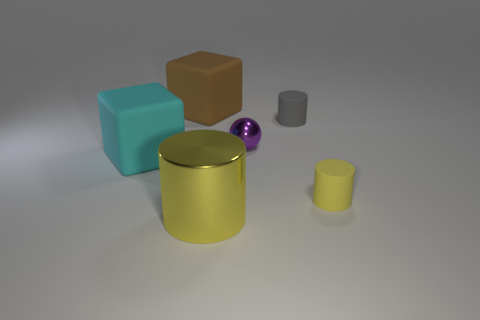What could these objects represent if they were symbolic? If we interpret the objects symbolically, the variety of geometric shapes and colors might represent diversity and individuality. The central yellow cylinder could symbolize a source of energy or light, the blocks might represent structure and stability, while the purple sphere could signify wholeness or unity. The different sizes could reflect the importance or influence of various elements in a system. 